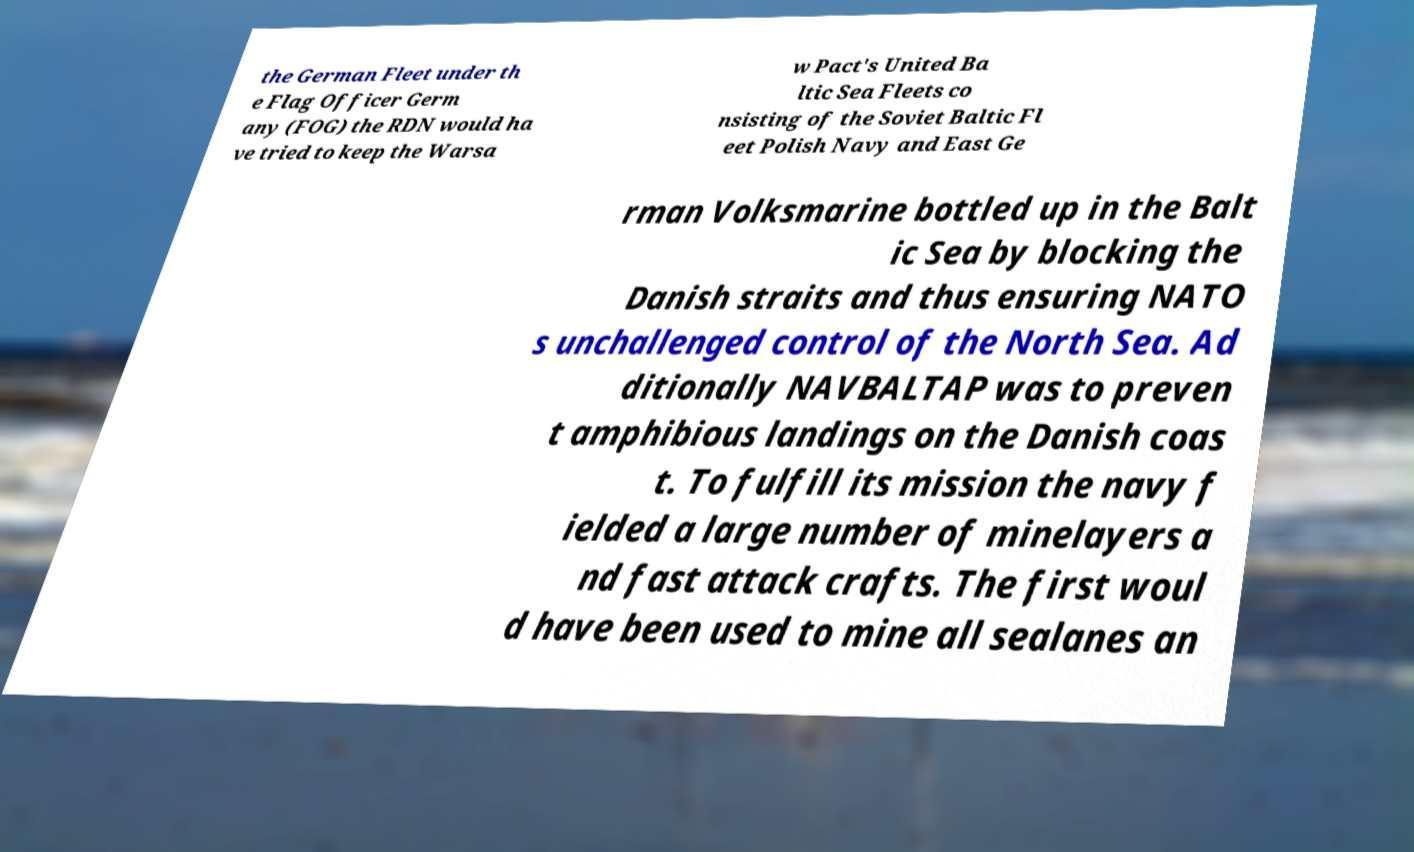What messages or text are displayed in this image? I need them in a readable, typed format. the German Fleet under th e Flag Officer Germ any (FOG) the RDN would ha ve tried to keep the Warsa w Pact's United Ba ltic Sea Fleets co nsisting of the Soviet Baltic Fl eet Polish Navy and East Ge rman Volksmarine bottled up in the Balt ic Sea by blocking the Danish straits and thus ensuring NATO s unchallenged control of the North Sea. Ad ditionally NAVBALTAP was to preven t amphibious landings on the Danish coas t. To fulfill its mission the navy f ielded a large number of minelayers a nd fast attack crafts. The first woul d have been used to mine all sealanes an 